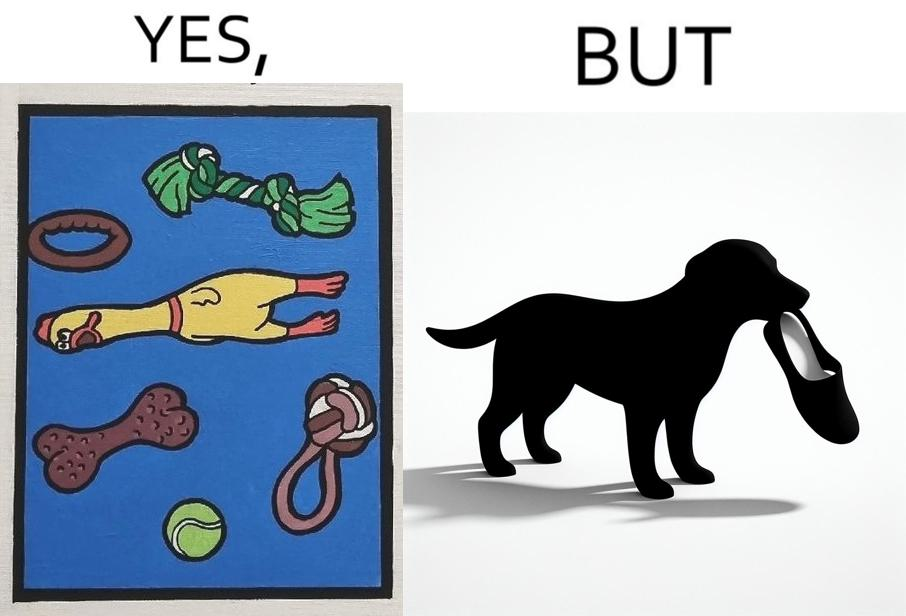What makes this image funny or satirical? the irony is that dog owners buy loads of toys for their dog but the dog's favourite toy is the owner's slippers 